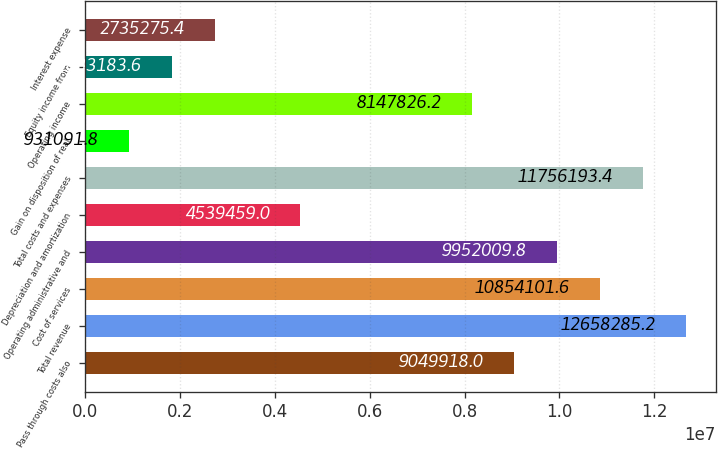Convert chart. <chart><loc_0><loc_0><loc_500><loc_500><bar_chart><fcel>Pass through costs also<fcel>Total revenue<fcel>Cost of services<fcel>Operating administrative and<fcel>Depreciation and amortization<fcel>Total costs and expenses<fcel>Gain on disposition of real<fcel>Operating income<fcel>Equity income from<fcel>Interest expense<nl><fcel>9.04992e+06<fcel>1.26583e+07<fcel>1.08541e+07<fcel>9.95201e+06<fcel>4.53946e+06<fcel>1.17562e+07<fcel>931092<fcel>8.14783e+06<fcel>1.83318e+06<fcel>2.73528e+06<nl></chart> 